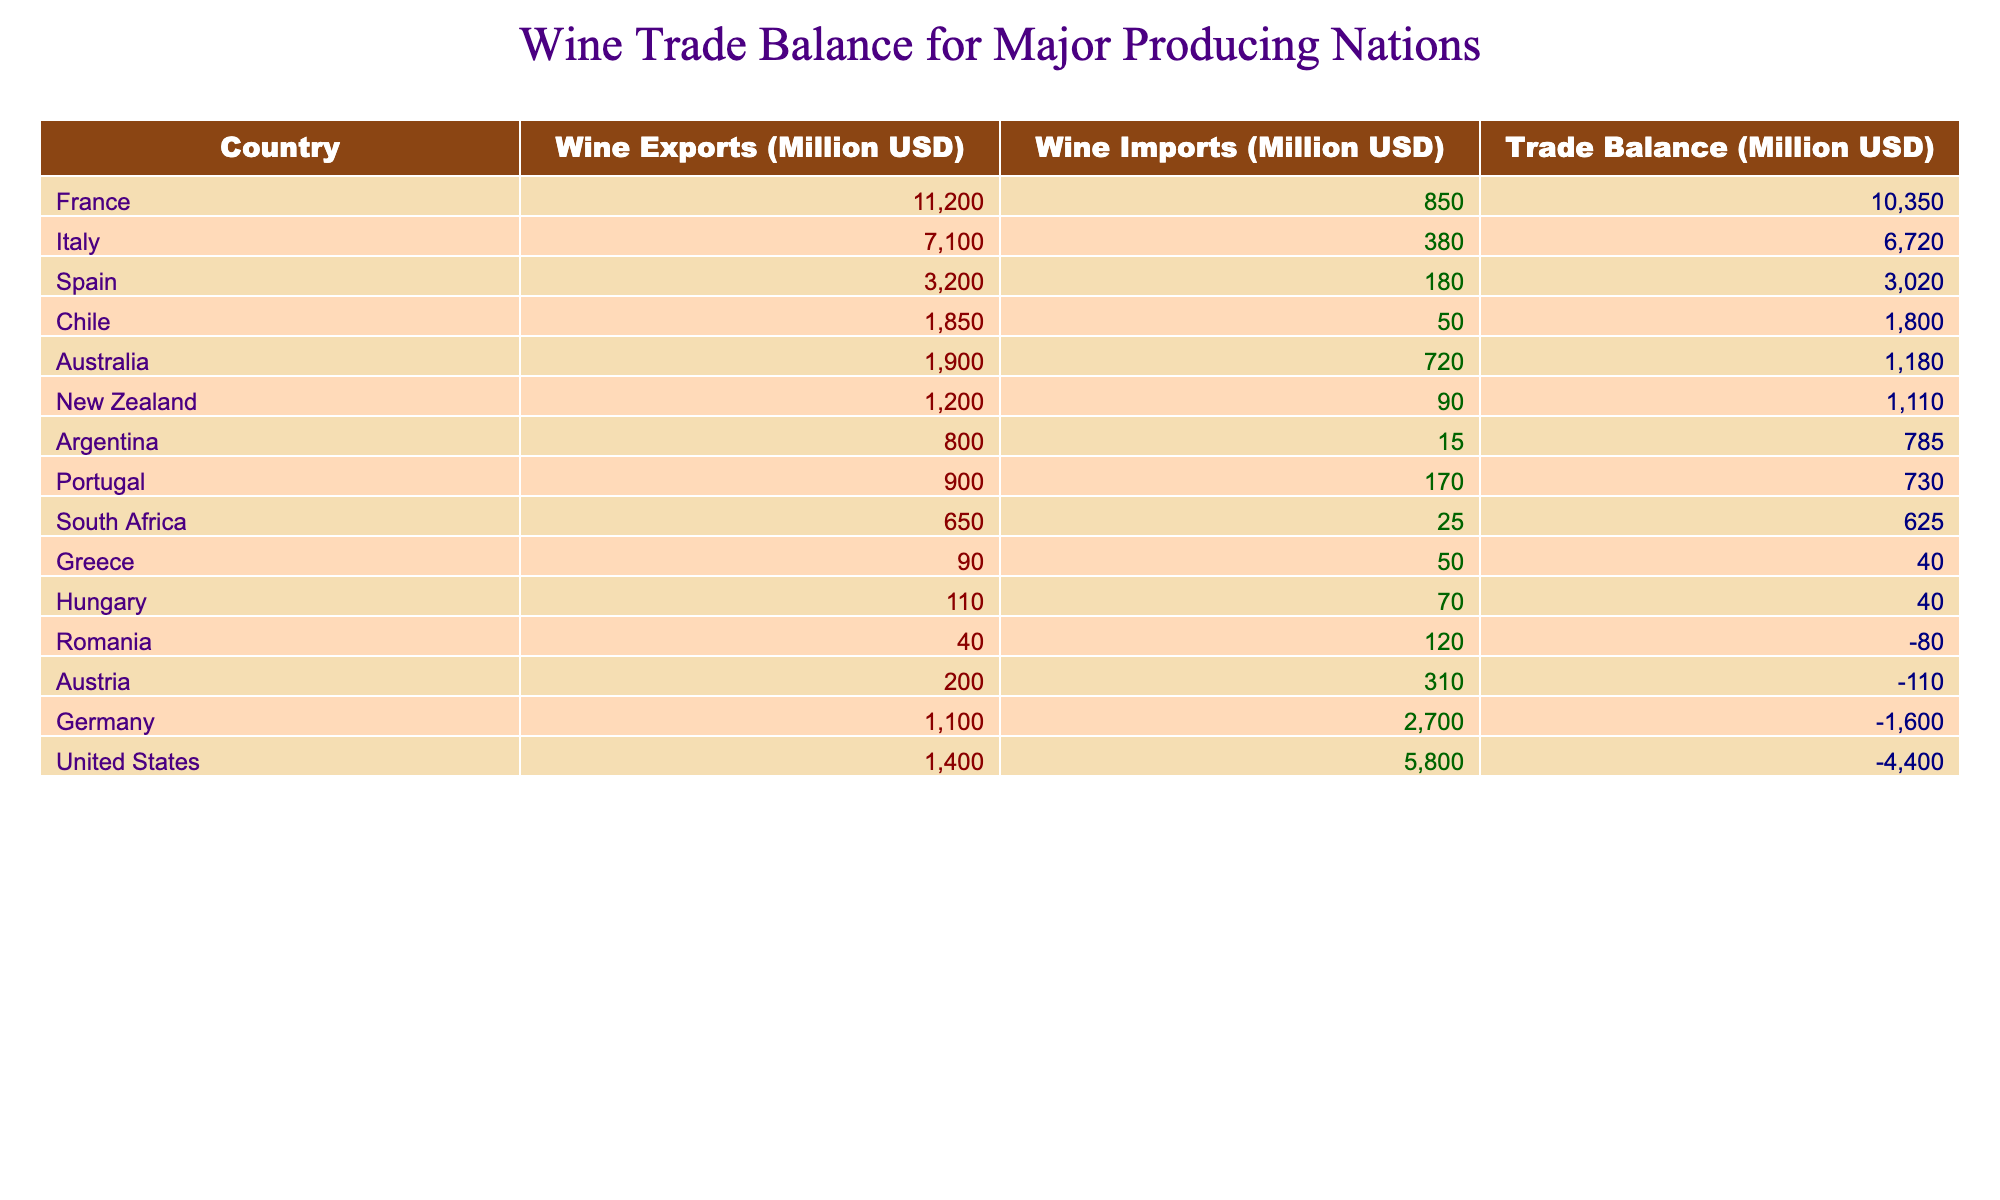What is the trade balance for France? The trade balance for France is explicitly listed in the table as 10,350 million USD.
Answer: 10,350 million USD Which country has the highest wine exports? By reviewing the 'Wine Exports' column, France has the highest exports at 11,200 million USD.
Answer: France What is the trade balance for the United States? The trade balance for the United States is displayed as -4,400 million USD in the table.
Answer: -4,400 million USD Which country has a positive trade balance but lower exports than Chile? Chile has exports of 1,850 million USD and a trade balance of 1,800 million USD. Argentina has a positive trade balance of 785 million USD with exports of 800 million USD, which is less than Chile's exports.
Answer: Argentina What is the total wine export value for the top three countries? The total wine exports for the top three countries (France, Italy, and Spain) can be calculated: 11,200 + 7,100 + 3,200 = 21,500 million USD.
Answer: 21,500 million USD Is Greece a net exporter or importer of wine? By looking at Greece's trade balance of 40 million USD, which is positive, it is clear that Greece is a net exporter of wine.
Answer: Yes, a net exporter What is the difference in trade balance between Italy and Germany? Italy's trade balance is 6,720 million USD and Germany's is -1,600 million USD. The difference can be calculated: 6,720 - (-1,600) = 8,320 million USD.
Answer: 8,320 million USD How many countries have a trade balance greater than 1,000 million USD? The countries with a trade balance greater than 1,000 million USD are France, Italy, Spain, Chile, Australia, and New Zealand, totaling six countries.
Answer: 6 countries What is the average trade balance for all the countries listed? To find the average, sum the trade balances: (10,350 + 6,720 + 3,020 + 1,180 + 1,800 - 4,400 - 1,600 + 1110 + 730 + 625 - 110 + 40 + 40 - 80) = 18,925 million USD. Then divide by the number of countries (14): 18,925 / 14 ≈ 1,352 million USD.
Answer: Approximately 1,352 million USD Which country has the smallest trade balance? By comparing the trade balances, the smallest is Romania with -80 million USD.
Answer: Romania 